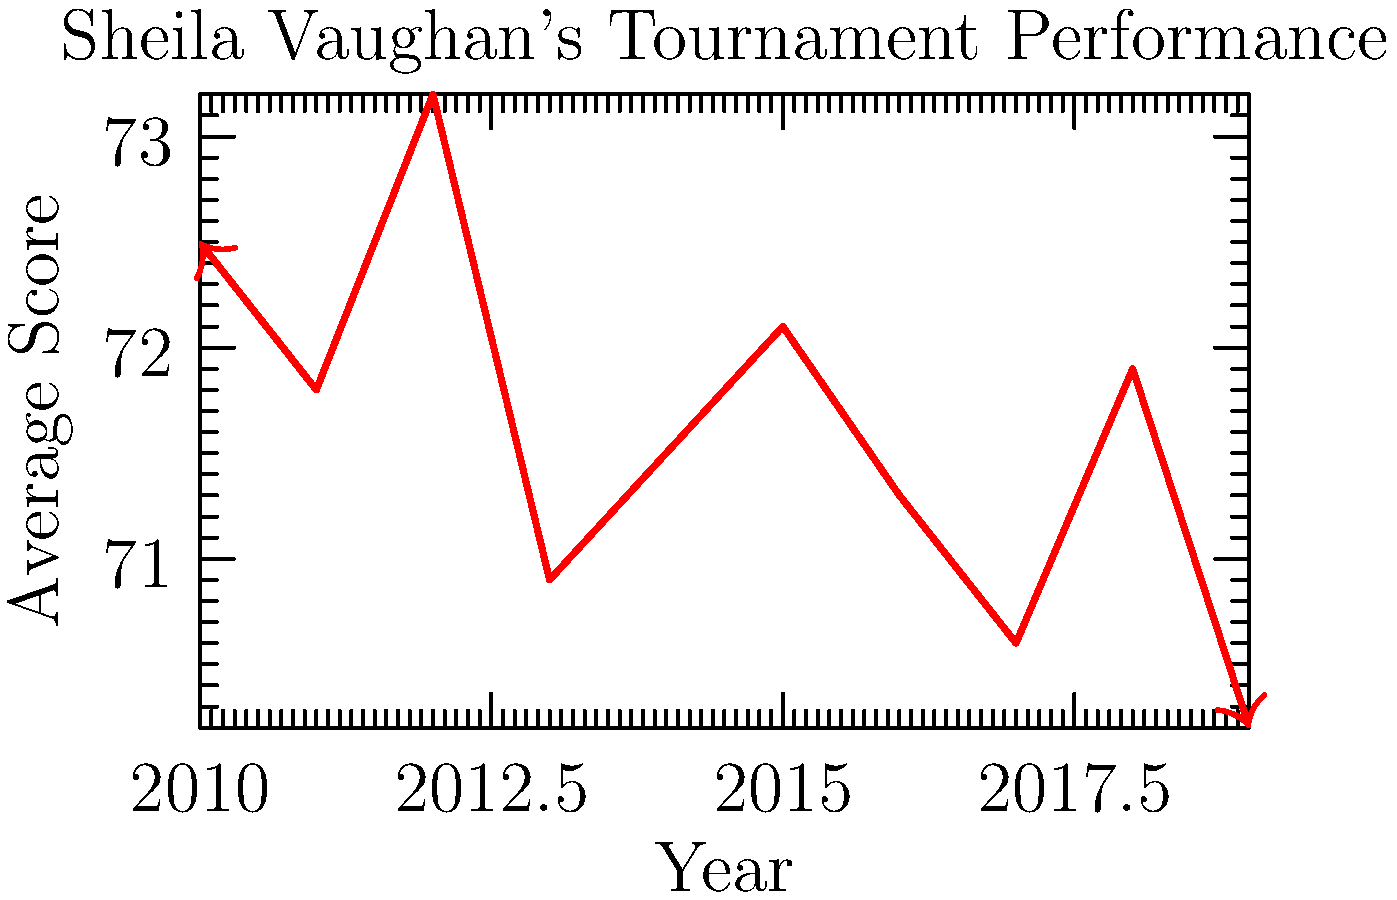Based on the line graph showing Sheila Vaughan's tournament performance over time, in which year did she achieve her best average score, and what was that score? To answer this question, we need to analyze the line graph representing Sheila Vaughan's tournament performance from 2010 to 2019. The y-axis shows the average score, where a lower score indicates better performance in golf.

Step 1: Identify the lowest point on the graph.
The lowest point on the graph represents the best (lowest) average score.

Step 2: Determine the year corresponding to the lowest point.
By tracing the lowest point to the x-axis, we can see that it corresponds to the year 2019.

Step 3: Read the average score for that year.
The y-value for the lowest point is approximately 70.2.

Therefore, Sheila Vaughan achieved her best average score in 2019, with a score of 70.2.
Answer: 2019, 70.2 